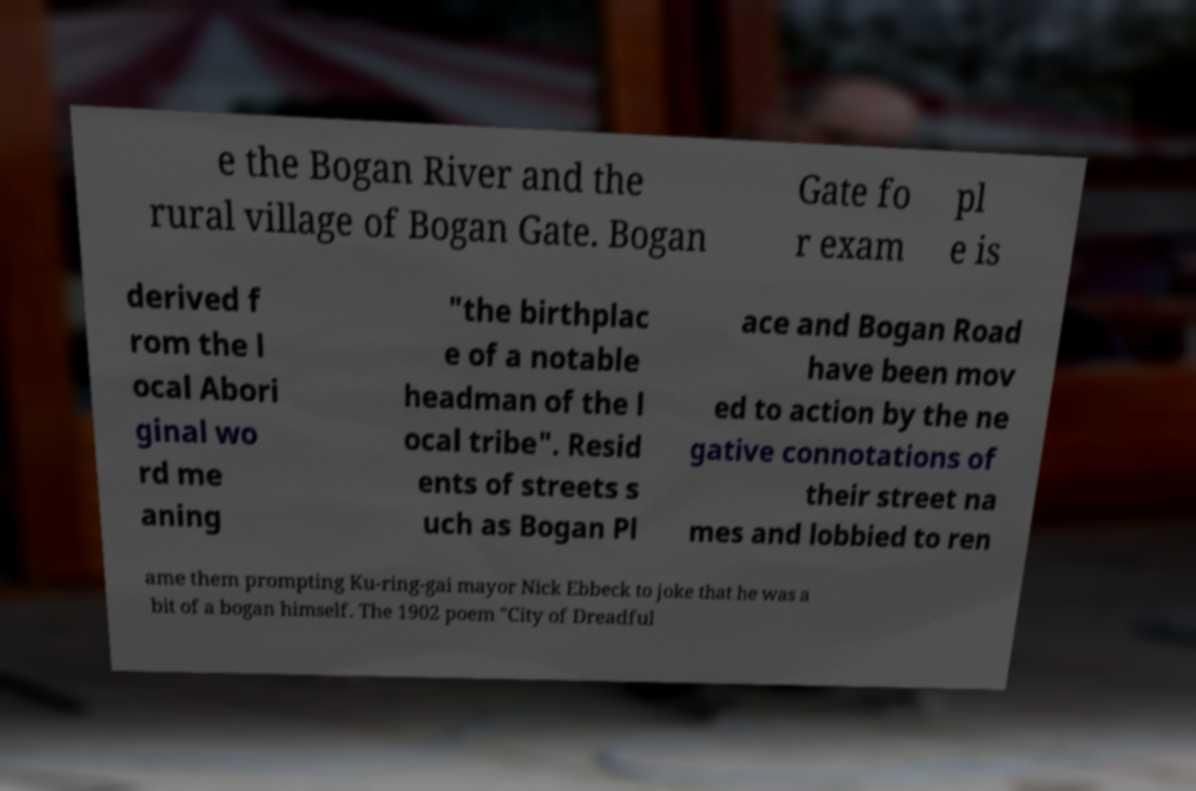For documentation purposes, I need the text within this image transcribed. Could you provide that? e the Bogan River and the rural village of Bogan Gate. Bogan Gate fo r exam pl e is derived f rom the l ocal Abori ginal wo rd me aning "the birthplac e of a notable headman of the l ocal tribe". Resid ents of streets s uch as Bogan Pl ace and Bogan Road have been mov ed to action by the ne gative connotations of their street na mes and lobbied to ren ame them prompting Ku-ring-gai mayor Nick Ebbeck to joke that he was a bit of a bogan himself. The 1902 poem "City of Dreadful 